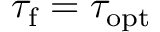<formula> <loc_0><loc_0><loc_500><loc_500>\tau _ { f } = \tau _ { o p t }</formula> 